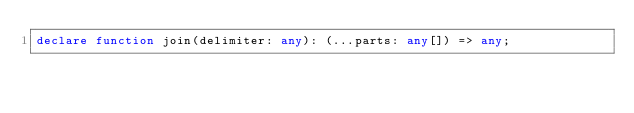<code> <loc_0><loc_0><loc_500><loc_500><_TypeScript_>declare function join(delimiter: any): (...parts: any[]) => any;
</code> 